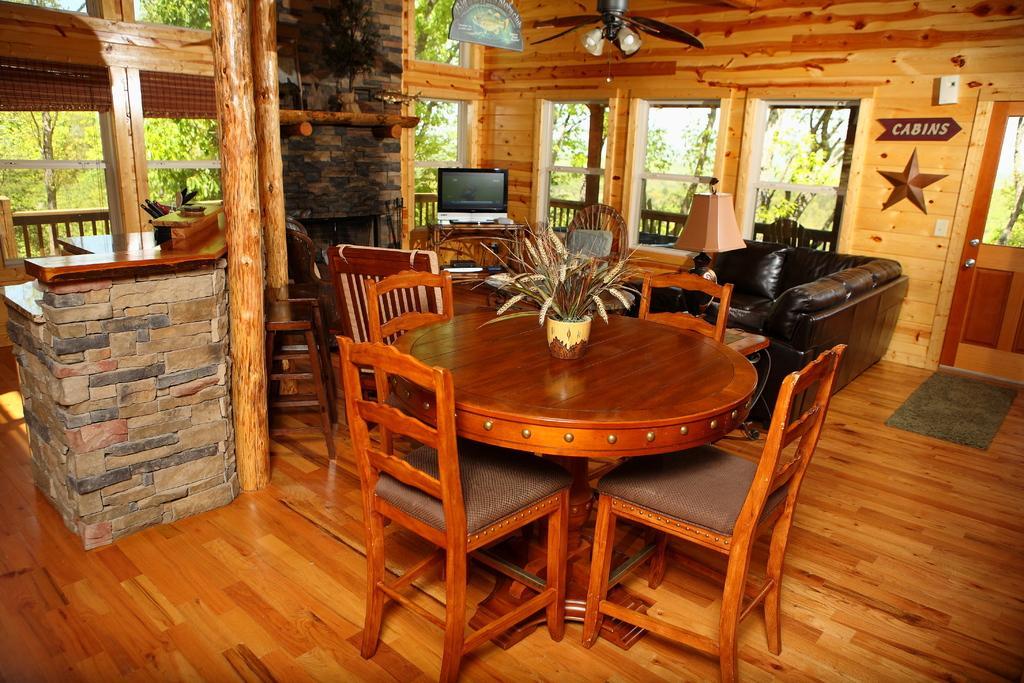How would you summarize this image in a sentence or two? In this room there is a flower vase on the table and around it there are chairs. In the background there are windows,wall,sofa,lamp,chair,TV and posters on the wall. Through windows we can see trees and sky. On the right there is a door. 